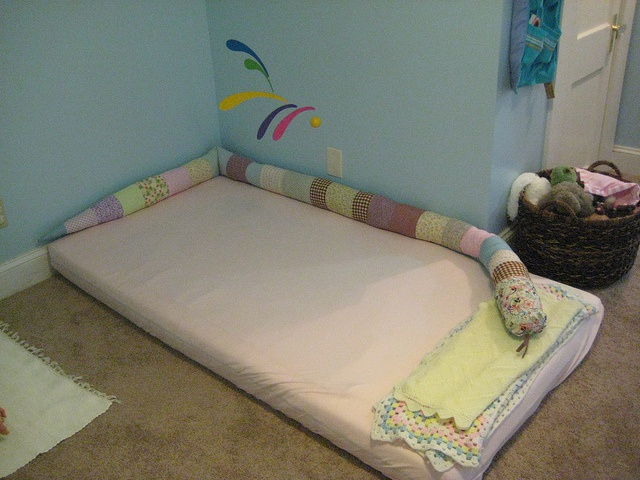Describe the objects in this image and their specific colors. I can see bed in teal, darkgray, gray, and tan tones and teddy bear in teal, gray, darkgreen, and black tones in this image. 